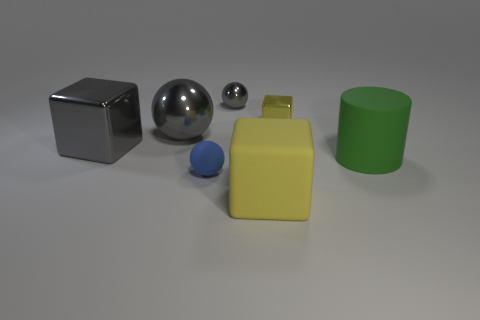Is there a big yellow cylinder made of the same material as the big green thing?
Offer a very short reply. No. Is the shape of the yellow metallic thing the same as the big object in front of the big green matte object?
Provide a short and direct response. Yes. Are there any small blue matte objects behind the large gray cube?
Your answer should be very brief. No. What number of big gray metal things are the same shape as the blue rubber object?
Make the answer very short. 1. Do the large yellow block and the large object on the right side of the big yellow matte thing have the same material?
Your answer should be very brief. Yes. How many big cyan spheres are there?
Your answer should be compact. 0. There is a metallic cube that is in front of the tiny yellow object; what is its size?
Provide a succinct answer. Large. What number of cyan rubber balls have the same size as the green object?
Offer a very short reply. 0. What is the big object that is both right of the tiny gray metallic thing and behind the large yellow cube made of?
Give a very brief answer. Rubber. There is a gray thing that is the same size as the yellow metallic thing; what is its material?
Provide a short and direct response. Metal. 